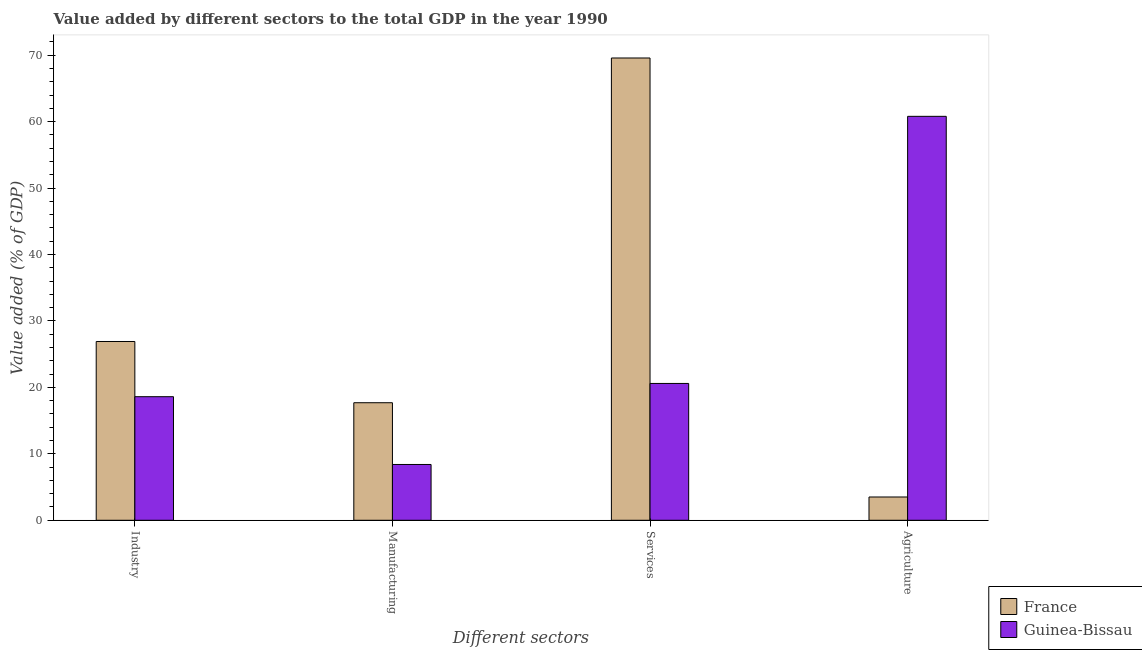How many groups of bars are there?
Your response must be concise. 4. Are the number of bars per tick equal to the number of legend labels?
Keep it short and to the point. Yes. How many bars are there on the 1st tick from the left?
Give a very brief answer. 2. How many bars are there on the 3rd tick from the right?
Make the answer very short. 2. What is the label of the 1st group of bars from the left?
Offer a very short reply. Industry. What is the value added by agricultural sector in Guinea-Bissau?
Keep it short and to the point. 60.8. Across all countries, what is the maximum value added by agricultural sector?
Give a very brief answer. 60.8. Across all countries, what is the minimum value added by manufacturing sector?
Keep it short and to the point. 8.4. In which country was the value added by agricultural sector minimum?
Ensure brevity in your answer.  France. What is the total value added by industrial sector in the graph?
Your answer should be very brief. 45.51. What is the difference between the value added by manufacturing sector in France and that in Guinea-Bissau?
Offer a very short reply. 9.29. What is the difference between the value added by industrial sector in France and the value added by manufacturing sector in Guinea-Bissau?
Your response must be concise. 18.51. What is the average value added by agricultural sector per country?
Your answer should be very brief. 32.15. What is the difference between the value added by agricultural sector and value added by industrial sector in France?
Offer a terse response. -23.41. In how many countries, is the value added by manufacturing sector greater than 36 %?
Ensure brevity in your answer.  0. What is the ratio of the value added by services sector in France to that in Guinea-Bissau?
Provide a short and direct response. 3.38. Is the value added by services sector in Guinea-Bissau less than that in France?
Provide a succinct answer. Yes. Is the difference between the value added by services sector in France and Guinea-Bissau greater than the difference between the value added by manufacturing sector in France and Guinea-Bissau?
Make the answer very short. Yes. What is the difference between the highest and the second highest value added by manufacturing sector?
Give a very brief answer. 9.29. What is the difference between the highest and the lowest value added by agricultural sector?
Keep it short and to the point. 57.3. In how many countries, is the value added by services sector greater than the average value added by services sector taken over all countries?
Offer a terse response. 1. Is it the case that in every country, the sum of the value added by services sector and value added by industrial sector is greater than the sum of value added by agricultural sector and value added by manufacturing sector?
Provide a succinct answer. Yes. What does the 1st bar from the left in Services represents?
Offer a very short reply. France. What does the 1st bar from the right in Industry represents?
Your response must be concise. Guinea-Bissau. Is it the case that in every country, the sum of the value added by industrial sector and value added by manufacturing sector is greater than the value added by services sector?
Your response must be concise. No. Are all the bars in the graph horizontal?
Ensure brevity in your answer.  No. How many countries are there in the graph?
Your answer should be very brief. 2. What is the difference between two consecutive major ticks on the Y-axis?
Offer a very short reply. 10. Does the graph contain any zero values?
Your answer should be very brief. No. Does the graph contain grids?
Provide a succinct answer. No. Where does the legend appear in the graph?
Offer a very short reply. Bottom right. How many legend labels are there?
Make the answer very short. 2. How are the legend labels stacked?
Keep it short and to the point. Vertical. What is the title of the graph?
Provide a succinct answer. Value added by different sectors to the total GDP in the year 1990. Does "Ukraine" appear as one of the legend labels in the graph?
Offer a terse response. No. What is the label or title of the X-axis?
Your response must be concise. Different sectors. What is the label or title of the Y-axis?
Your answer should be very brief. Value added (% of GDP). What is the Value added (% of GDP) in France in Industry?
Ensure brevity in your answer.  26.91. What is the Value added (% of GDP) in Guinea-Bissau in Industry?
Make the answer very short. 18.6. What is the Value added (% of GDP) in France in Manufacturing?
Your answer should be compact. 17.69. What is the Value added (% of GDP) of Guinea-Bissau in Manufacturing?
Your response must be concise. 8.4. What is the Value added (% of GDP) in France in Services?
Provide a succinct answer. 69.59. What is the Value added (% of GDP) in Guinea-Bissau in Services?
Ensure brevity in your answer.  20.6. What is the Value added (% of GDP) of France in Agriculture?
Make the answer very short. 3.5. What is the Value added (% of GDP) in Guinea-Bissau in Agriculture?
Your answer should be compact. 60.8. Across all Different sectors, what is the maximum Value added (% of GDP) in France?
Your response must be concise. 69.59. Across all Different sectors, what is the maximum Value added (% of GDP) in Guinea-Bissau?
Offer a terse response. 60.8. Across all Different sectors, what is the minimum Value added (% of GDP) of France?
Ensure brevity in your answer.  3.5. Across all Different sectors, what is the minimum Value added (% of GDP) in Guinea-Bissau?
Your answer should be very brief. 8.4. What is the total Value added (% of GDP) of France in the graph?
Keep it short and to the point. 117.69. What is the total Value added (% of GDP) of Guinea-Bissau in the graph?
Your response must be concise. 108.4. What is the difference between the Value added (% of GDP) in France in Industry and that in Manufacturing?
Your response must be concise. 9.22. What is the difference between the Value added (% of GDP) in Guinea-Bissau in Industry and that in Manufacturing?
Offer a terse response. 10.2. What is the difference between the Value added (% of GDP) in France in Industry and that in Services?
Provide a succinct answer. -42.67. What is the difference between the Value added (% of GDP) in Guinea-Bissau in Industry and that in Services?
Ensure brevity in your answer.  -1.99. What is the difference between the Value added (% of GDP) of France in Industry and that in Agriculture?
Make the answer very short. 23.41. What is the difference between the Value added (% of GDP) of Guinea-Bissau in Industry and that in Agriculture?
Provide a short and direct response. -42.2. What is the difference between the Value added (% of GDP) of France in Manufacturing and that in Services?
Ensure brevity in your answer.  -51.89. What is the difference between the Value added (% of GDP) in Guinea-Bissau in Manufacturing and that in Services?
Keep it short and to the point. -12.2. What is the difference between the Value added (% of GDP) in France in Manufacturing and that in Agriculture?
Provide a short and direct response. 14.19. What is the difference between the Value added (% of GDP) of Guinea-Bissau in Manufacturing and that in Agriculture?
Make the answer very short. -52.4. What is the difference between the Value added (% of GDP) in France in Services and that in Agriculture?
Your answer should be very brief. 66.08. What is the difference between the Value added (% of GDP) in Guinea-Bissau in Services and that in Agriculture?
Keep it short and to the point. -40.21. What is the difference between the Value added (% of GDP) in France in Industry and the Value added (% of GDP) in Guinea-Bissau in Manufacturing?
Keep it short and to the point. 18.51. What is the difference between the Value added (% of GDP) of France in Industry and the Value added (% of GDP) of Guinea-Bissau in Services?
Provide a short and direct response. 6.31. What is the difference between the Value added (% of GDP) of France in Industry and the Value added (% of GDP) of Guinea-Bissau in Agriculture?
Offer a terse response. -33.89. What is the difference between the Value added (% of GDP) of France in Manufacturing and the Value added (% of GDP) of Guinea-Bissau in Services?
Offer a very short reply. -2.9. What is the difference between the Value added (% of GDP) in France in Manufacturing and the Value added (% of GDP) in Guinea-Bissau in Agriculture?
Your answer should be very brief. -43.11. What is the difference between the Value added (% of GDP) in France in Services and the Value added (% of GDP) in Guinea-Bissau in Agriculture?
Offer a terse response. 8.78. What is the average Value added (% of GDP) of France per Different sectors?
Your answer should be very brief. 29.42. What is the average Value added (% of GDP) in Guinea-Bissau per Different sectors?
Offer a very short reply. 27.1. What is the difference between the Value added (% of GDP) in France and Value added (% of GDP) in Guinea-Bissau in Industry?
Your response must be concise. 8.31. What is the difference between the Value added (% of GDP) in France and Value added (% of GDP) in Guinea-Bissau in Manufacturing?
Offer a terse response. 9.29. What is the difference between the Value added (% of GDP) of France and Value added (% of GDP) of Guinea-Bissau in Services?
Your answer should be compact. 48.99. What is the difference between the Value added (% of GDP) of France and Value added (% of GDP) of Guinea-Bissau in Agriculture?
Your answer should be very brief. -57.3. What is the ratio of the Value added (% of GDP) in France in Industry to that in Manufacturing?
Make the answer very short. 1.52. What is the ratio of the Value added (% of GDP) of Guinea-Bissau in Industry to that in Manufacturing?
Provide a short and direct response. 2.21. What is the ratio of the Value added (% of GDP) in France in Industry to that in Services?
Keep it short and to the point. 0.39. What is the ratio of the Value added (% of GDP) of Guinea-Bissau in Industry to that in Services?
Your answer should be very brief. 0.9. What is the ratio of the Value added (% of GDP) of France in Industry to that in Agriculture?
Your answer should be compact. 7.68. What is the ratio of the Value added (% of GDP) in Guinea-Bissau in Industry to that in Agriculture?
Provide a succinct answer. 0.31. What is the ratio of the Value added (% of GDP) of France in Manufacturing to that in Services?
Ensure brevity in your answer.  0.25. What is the ratio of the Value added (% of GDP) in Guinea-Bissau in Manufacturing to that in Services?
Provide a succinct answer. 0.41. What is the ratio of the Value added (% of GDP) of France in Manufacturing to that in Agriculture?
Offer a terse response. 5.05. What is the ratio of the Value added (% of GDP) in Guinea-Bissau in Manufacturing to that in Agriculture?
Make the answer very short. 0.14. What is the ratio of the Value added (% of GDP) of France in Services to that in Agriculture?
Your response must be concise. 19.86. What is the ratio of the Value added (% of GDP) of Guinea-Bissau in Services to that in Agriculture?
Offer a terse response. 0.34. What is the difference between the highest and the second highest Value added (% of GDP) in France?
Your answer should be compact. 42.67. What is the difference between the highest and the second highest Value added (% of GDP) in Guinea-Bissau?
Give a very brief answer. 40.21. What is the difference between the highest and the lowest Value added (% of GDP) of France?
Keep it short and to the point. 66.08. What is the difference between the highest and the lowest Value added (% of GDP) in Guinea-Bissau?
Your answer should be compact. 52.4. 